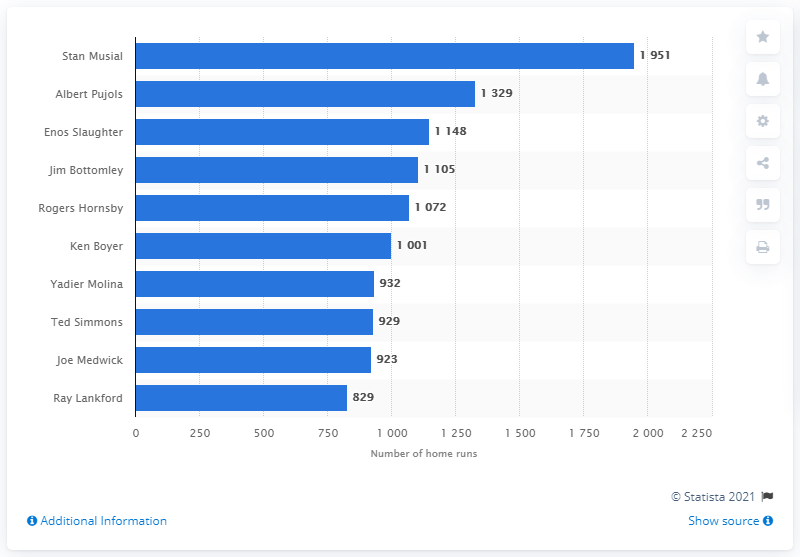Identify some key points in this picture. With a total of 1,377 RBI, Stan Musial is the all-time leader in RBI for the St. Louis Cardinals franchise history. 